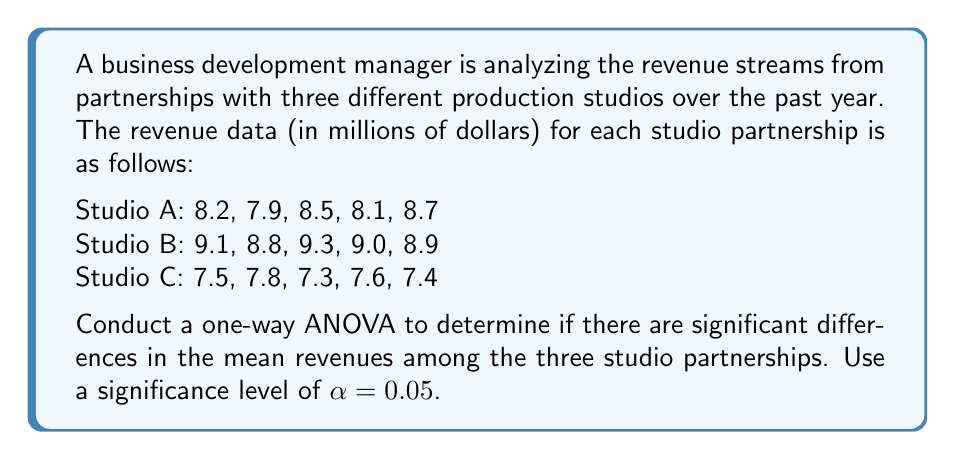Could you help me with this problem? To conduct a one-way ANOVA, we'll follow these steps:

1. Calculate the sum, mean, and variance for each group:

Studio A:
Sum = $\sum_{i=1}^{5} x_i = 41.4$
Mean = $\bar{x}_A = \frac{41.4}{5} = 8.28$
Variance = $s_A^2 = \frac{\sum_{i=1}^{5} (x_i - \bar{x}_A)^2}{5-1} = 0.107$

Studio B:
Sum = $\sum_{i=1}^{5} x_i = 45.1$
Mean = $\bar{x}_B = \frac{45.1}{5} = 9.02$
Variance = $s_B^2 = \frac{\sum_{i=1}^{5} (x_i - \bar{x}_B)^2}{5-1} = 0.037$

Studio C:
Sum = $\sum_{i=1}^{5} x_i = 37.6$
Mean = $\bar{x}_C = \frac{37.6}{5} = 7.52$
Variance = $s_C^2 = \frac{\sum_{i=1}^{5} (x_i - \bar{x}_C)^2}{5-1} = 0.037$

2. Calculate the overall mean:
$\bar{x} = \frac{41.4 + 45.1 + 37.6}{15} = 8.27$

3. Calculate the Sum of Squares Between (SSB):
$$SSB = \sum_{j=1}^{k} n_j(\bar{x}_j - \bar{x})^2$$
$$SSB = 5(8.28 - 8.27)^2 + 5(9.02 - 8.27)^2 + 5(7.52 - 8.27)^2 = 6.8134$$

4. Calculate the Sum of Squares Within (SSW):
$$SSW = \sum_{j=1}^{k} (n_j - 1)s_j^2$$
$$SSW = 4(0.107) + 4(0.037) + 4(0.037) = 0.724$$

5. Calculate the Sum of Squares Total (SST):
$$SST = SSB + SSW = 6.8134 + 0.724 = 7.5374$$

6. Calculate the degrees of freedom:
$df_{between} = k - 1 = 3 - 1 = 2$
$df_{within} = N - k = 15 - 3 = 12$
$df_{total} = N - 1 = 15 - 1 = 14$

7. Calculate the Mean Square Between (MSB) and Mean Square Within (MSW):
$$MSB = \frac{SSB}{df_{between}} = \frac{6.8134}{2} = 3.4067$$
$$MSW = \frac{SSW}{df_{within}} = \frac{0.724}{12} = 0.0603$$

8. Calculate the F-statistic:
$$F = \frac{MSB}{MSW} = \frac{3.4067}{0.0603} = 56.4959$$

9. Find the critical F-value:
For $\alpha = 0.05$, $df_{between} = 2$, and $df_{within} = 12$, the critical F-value is approximately 3.89.

10. Compare the F-statistic to the critical F-value:
Since $56.4959 > 3.89$, we reject the null hypothesis.
Answer: The one-way ANOVA results show a significant difference in mean revenues among the three studio partnerships (F(2, 12) = 56.4959, p < 0.05). We reject the null hypothesis and conclude that there are statistically significant differences in the revenue streams from the different production studio partnerships. 